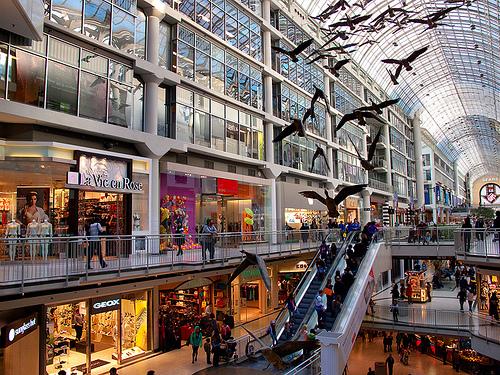How many birds are in the picture?
Be succinct. 24. Where is this?
Concise answer only. Mall. What famous song is also the name of a store pictured here?
Give a very brief answer. La vie en rose. Is this a terminal?
Concise answer only. No. What fast food restaurant can be seen?
Concise answer only. Mcdonald's. 